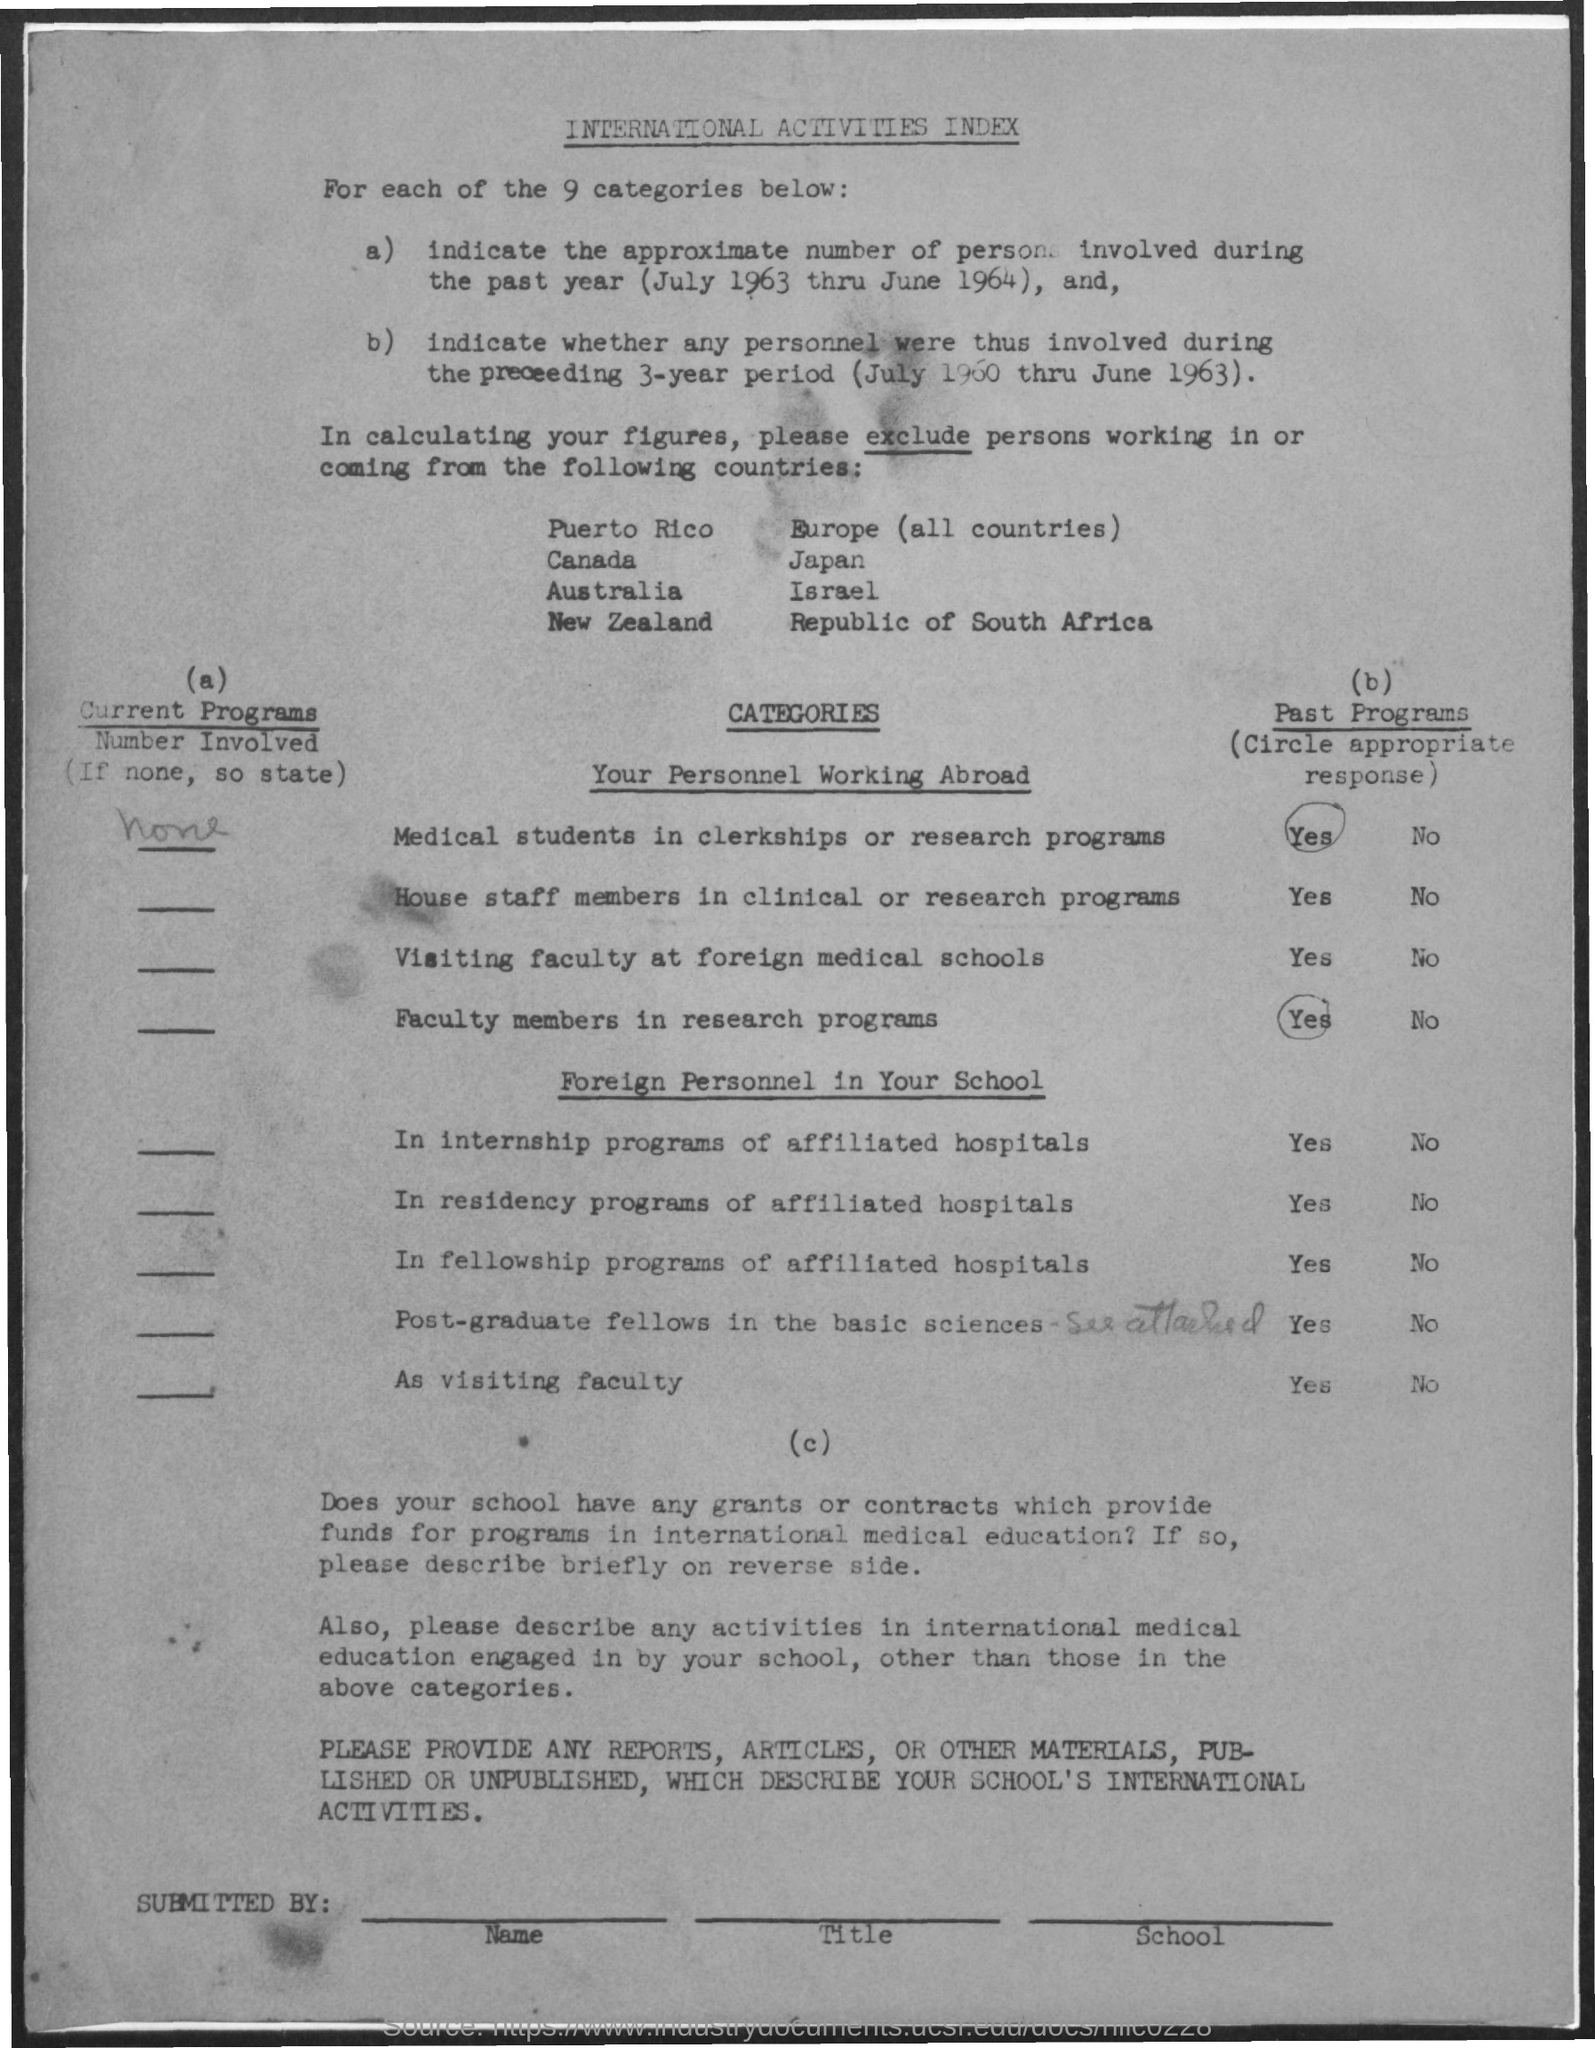What is the title of the document?
Offer a very short reply. International Activities Index. How many categories are there?
Your answer should be compact. 9. 